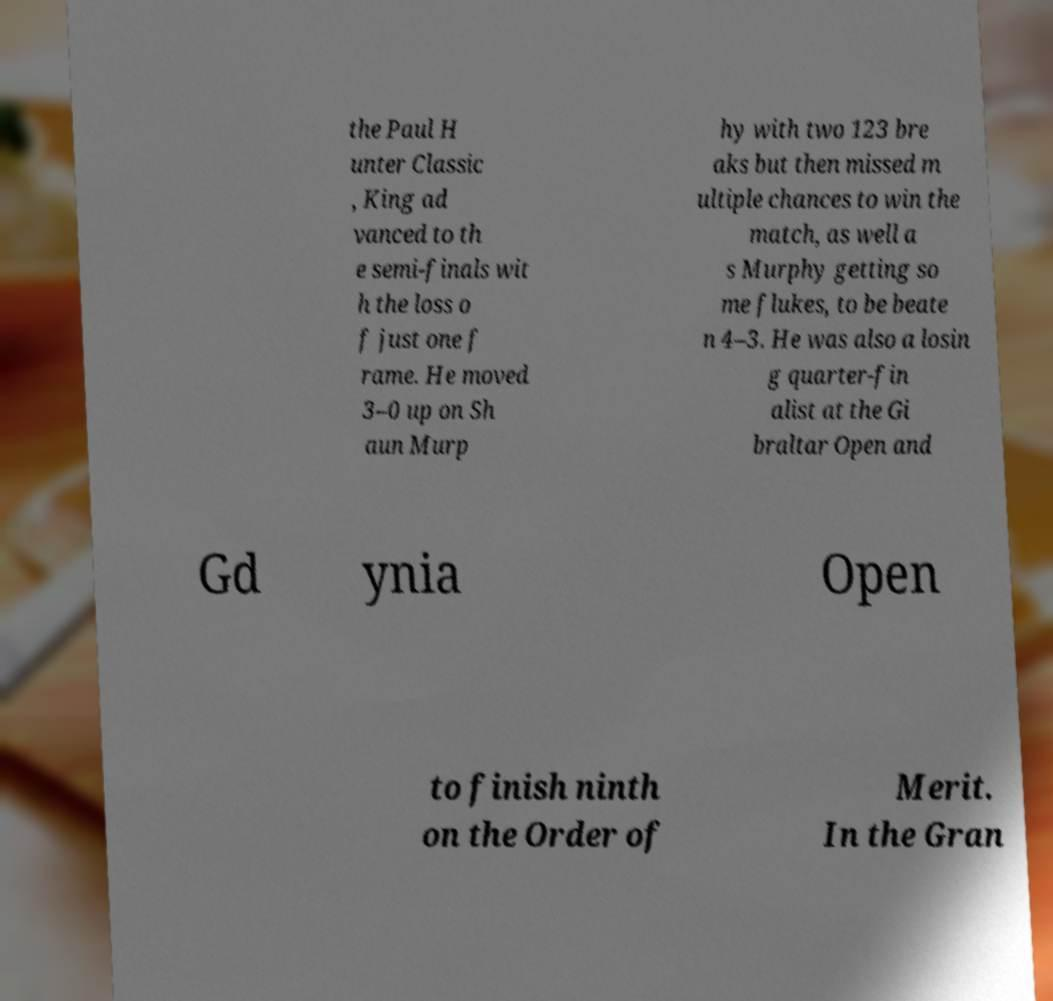Please read and relay the text visible in this image. What does it say? the Paul H unter Classic , King ad vanced to th e semi-finals wit h the loss o f just one f rame. He moved 3–0 up on Sh aun Murp hy with two 123 bre aks but then missed m ultiple chances to win the match, as well a s Murphy getting so me flukes, to be beate n 4–3. He was also a losin g quarter-fin alist at the Gi braltar Open and Gd ynia Open to finish ninth on the Order of Merit. In the Gran 